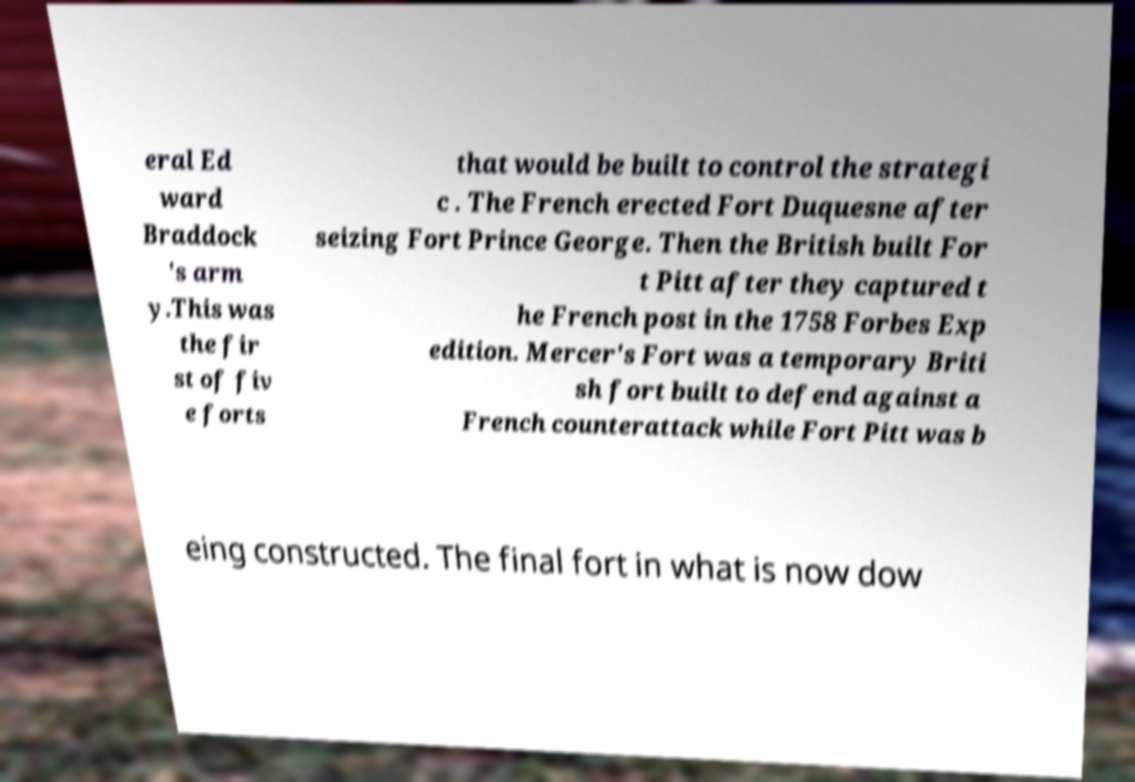What messages or text are displayed in this image? I need them in a readable, typed format. eral Ed ward Braddock 's arm y.This was the fir st of fiv e forts that would be built to control the strategi c . The French erected Fort Duquesne after seizing Fort Prince George. Then the British built For t Pitt after they captured t he French post in the 1758 Forbes Exp edition. Mercer's Fort was a temporary Briti sh fort built to defend against a French counterattack while Fort Pitt was b eing constructed. The final fort in what is now dow 